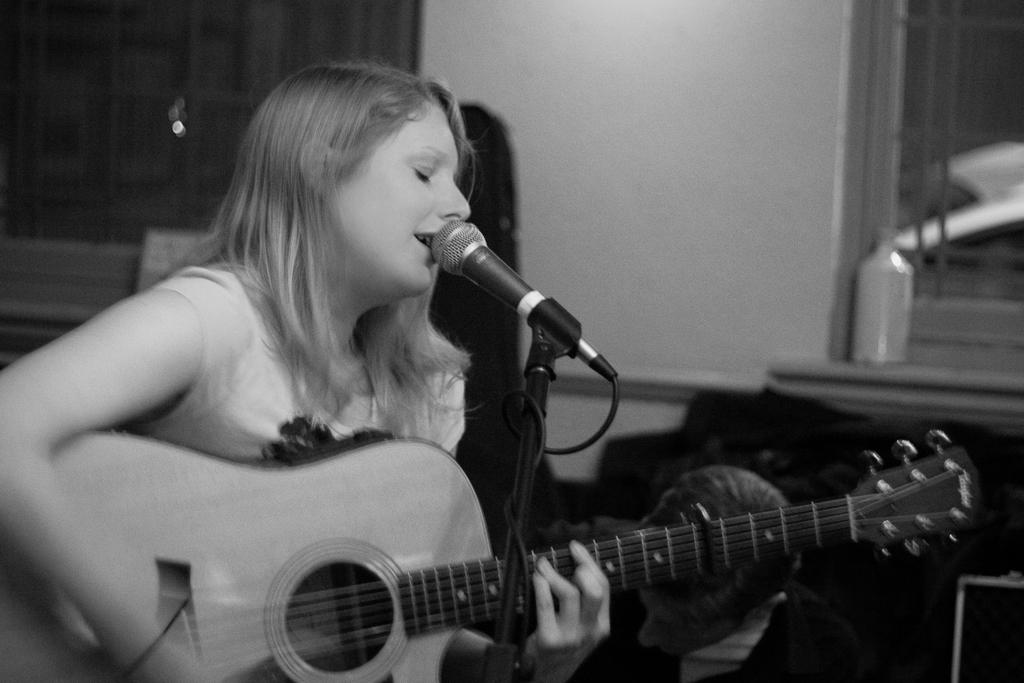Who is the main subject in the image? There is a girl in the image. What is the girl doing in the image? The girl is singing and playing a guitar. What tool is the girl using to amplify her voice? The girl is using a microphone in the image. What type of toothbrush is the girl using while playing the guitar? There is no toothbrush present in the image; the girl is using a microphone to amplify her voice while playing the guitar. 